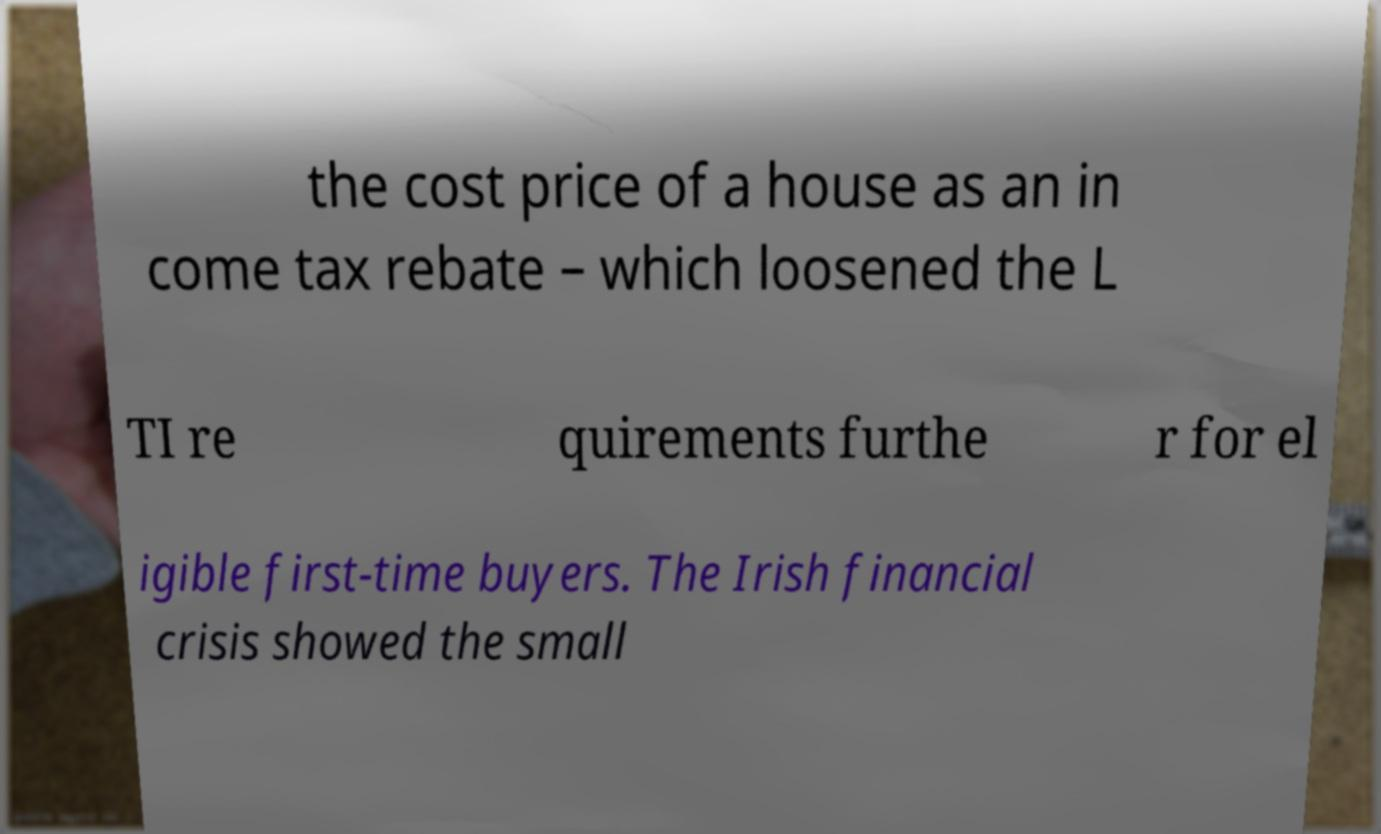I need the written content from this picture converted into text. Can you do that? the cost price of a house as an in come tax rebate – which loosened the L TI re quirements furthe r for el igible first-time buyers. The Irish financial crisis showed the small 